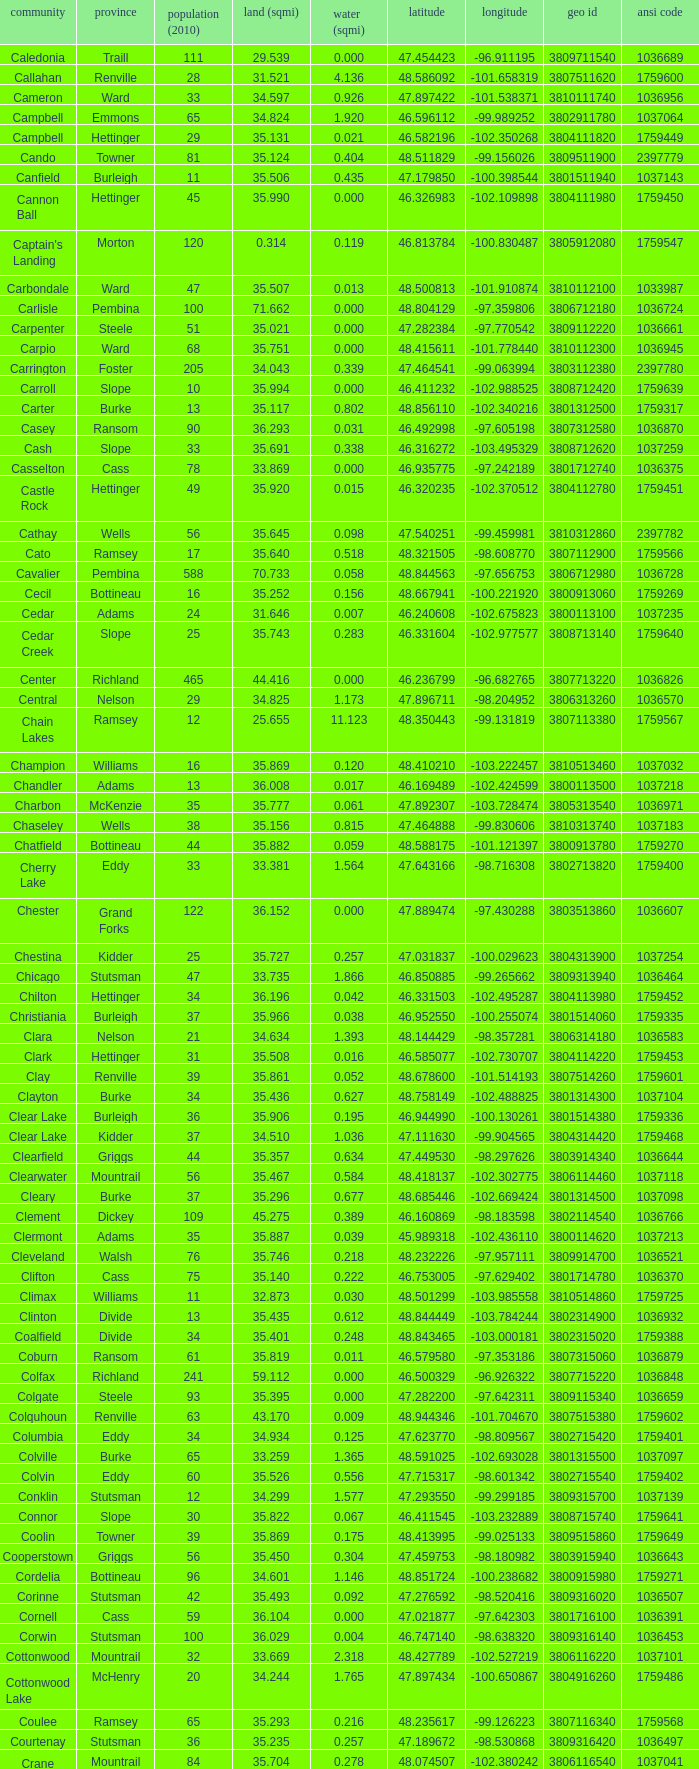Which county had a longitude of -102.302775? Mountrail. 